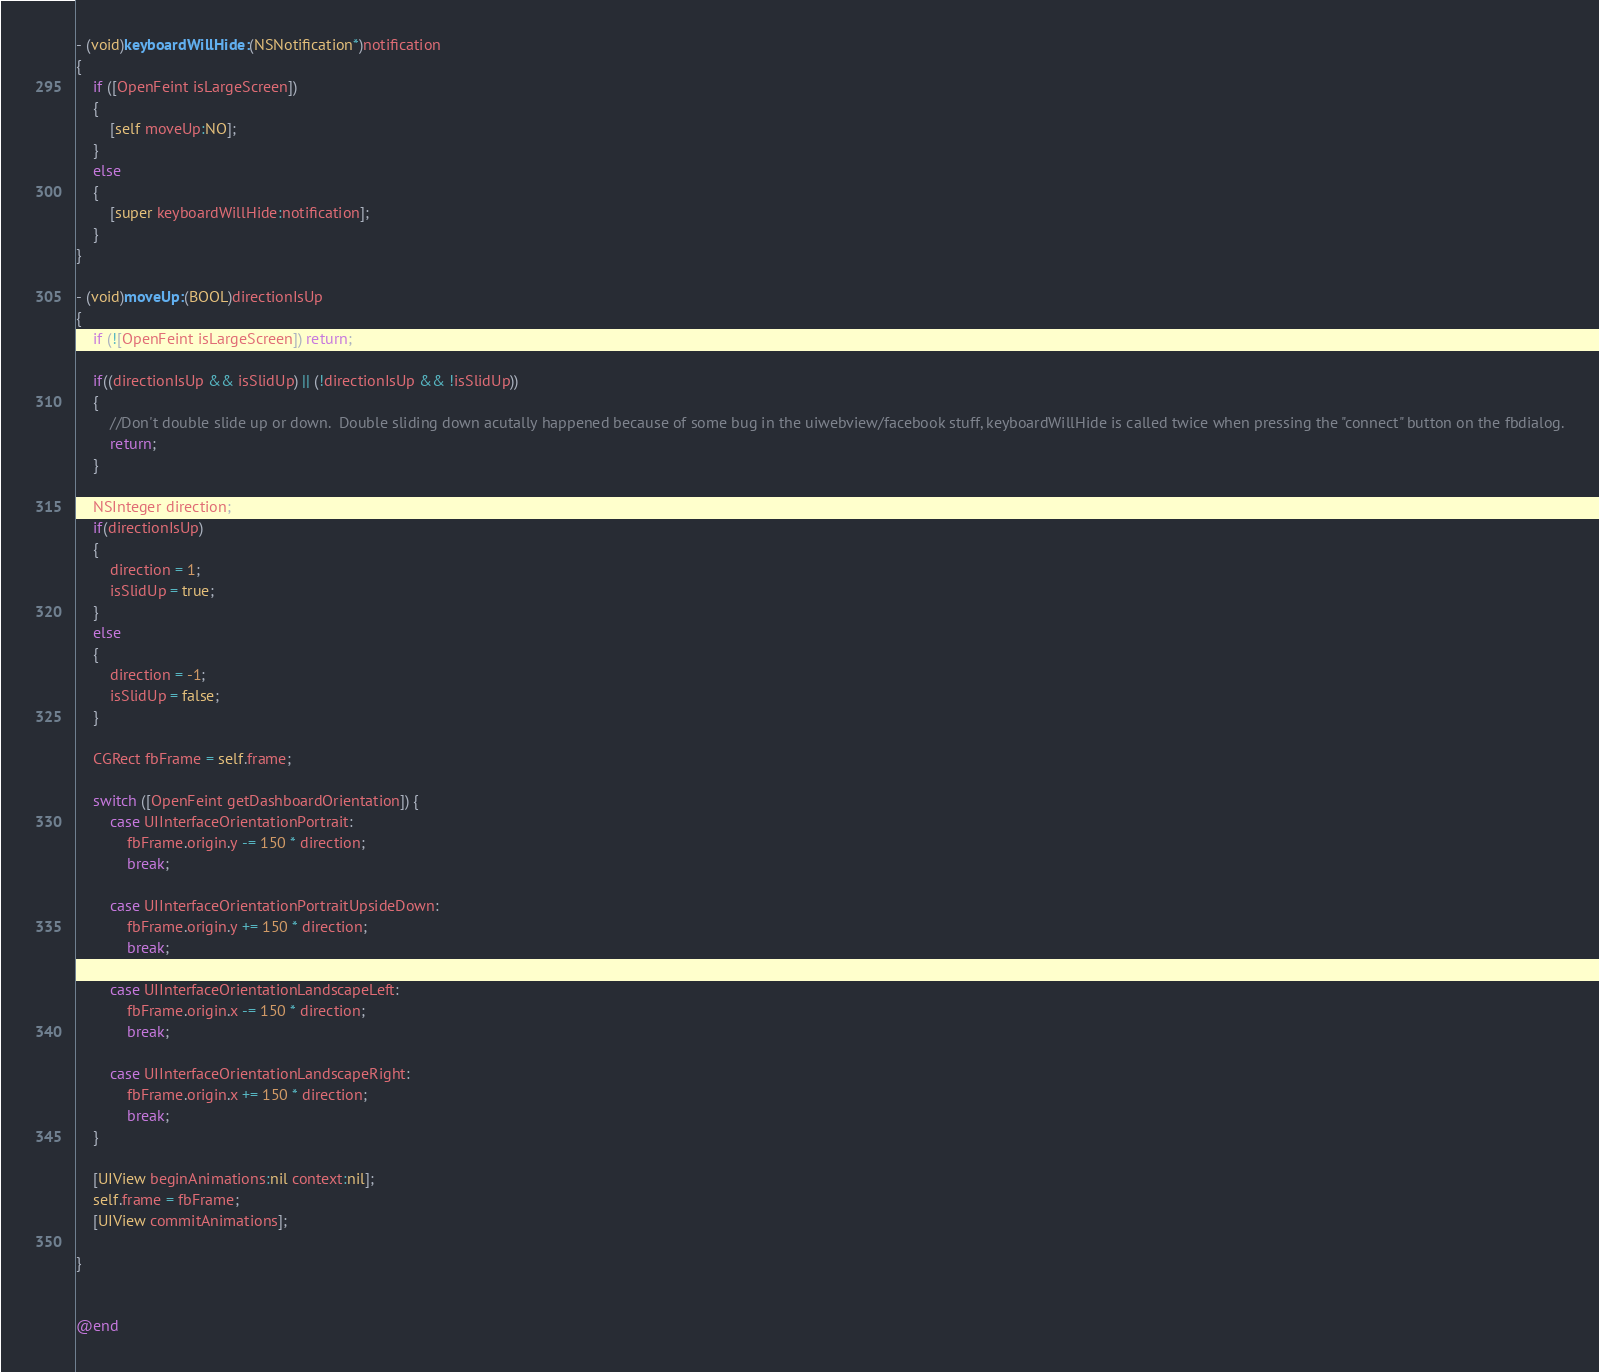<code> <loc_0><loc_0><loc_500><loc_500><_ObjectiveC_>
- (void)keyboardWillHide:(NSNotification*)notification
{
    if ([OpenFeint isLargeScreen])
    {
        [self moveUp:NO];
    }
    else
    {
        [super keyboardWillHide:notification];
    }
}

- (void)moveUp:(BOOL)directionIsUp
{
    if (![OpenFeint isLargeScreen]) return;
	
	if((directionIsUp && isSlidUp) || (!directionIsUp && !isSlidUp))
	{
		//Don't double slide up or down.  Double sliding down acutally happened because of some bug in the uiwebview/facebook stuff, keyboardWillHide is called twice when pressing the "connect" button on the fbdialog.
		return;
	}
    
    NSInteger direction;
	if(directionIsUp)
	{
		direction = 1;
		isSlidUp = true;
	}
	else
	{
		direction = -1;
		isSlidUp = false;
	}
	
    CGRect fbFrame = self.frame;
    
    switch ([OpenFeint getDashboardOrientation]) {
        case UIInterfaceOrientationPortrait:
            fbFrame.origin.y -= 150 * direction;
            break;
            
        case UIInterfaceOrientationPortraitUpsideDown:
            fbFrame.origin.y += 150 * direction;
            break;
            
        case UIInterfaceOrientationLandscapeLeft:
            fbFrame.origin.x -= 150 * direction;
            break;
            
        case UIInterfaceOrientationLandscapeRight:
            fbFrame.origin.x += 150 * direction;
            break;            
    }
    
    [UIView beginAnimations:nil context:nil];
    self.frame = fbFrame;
    [UIView commitAnimations];
    
}


@end
</code> 